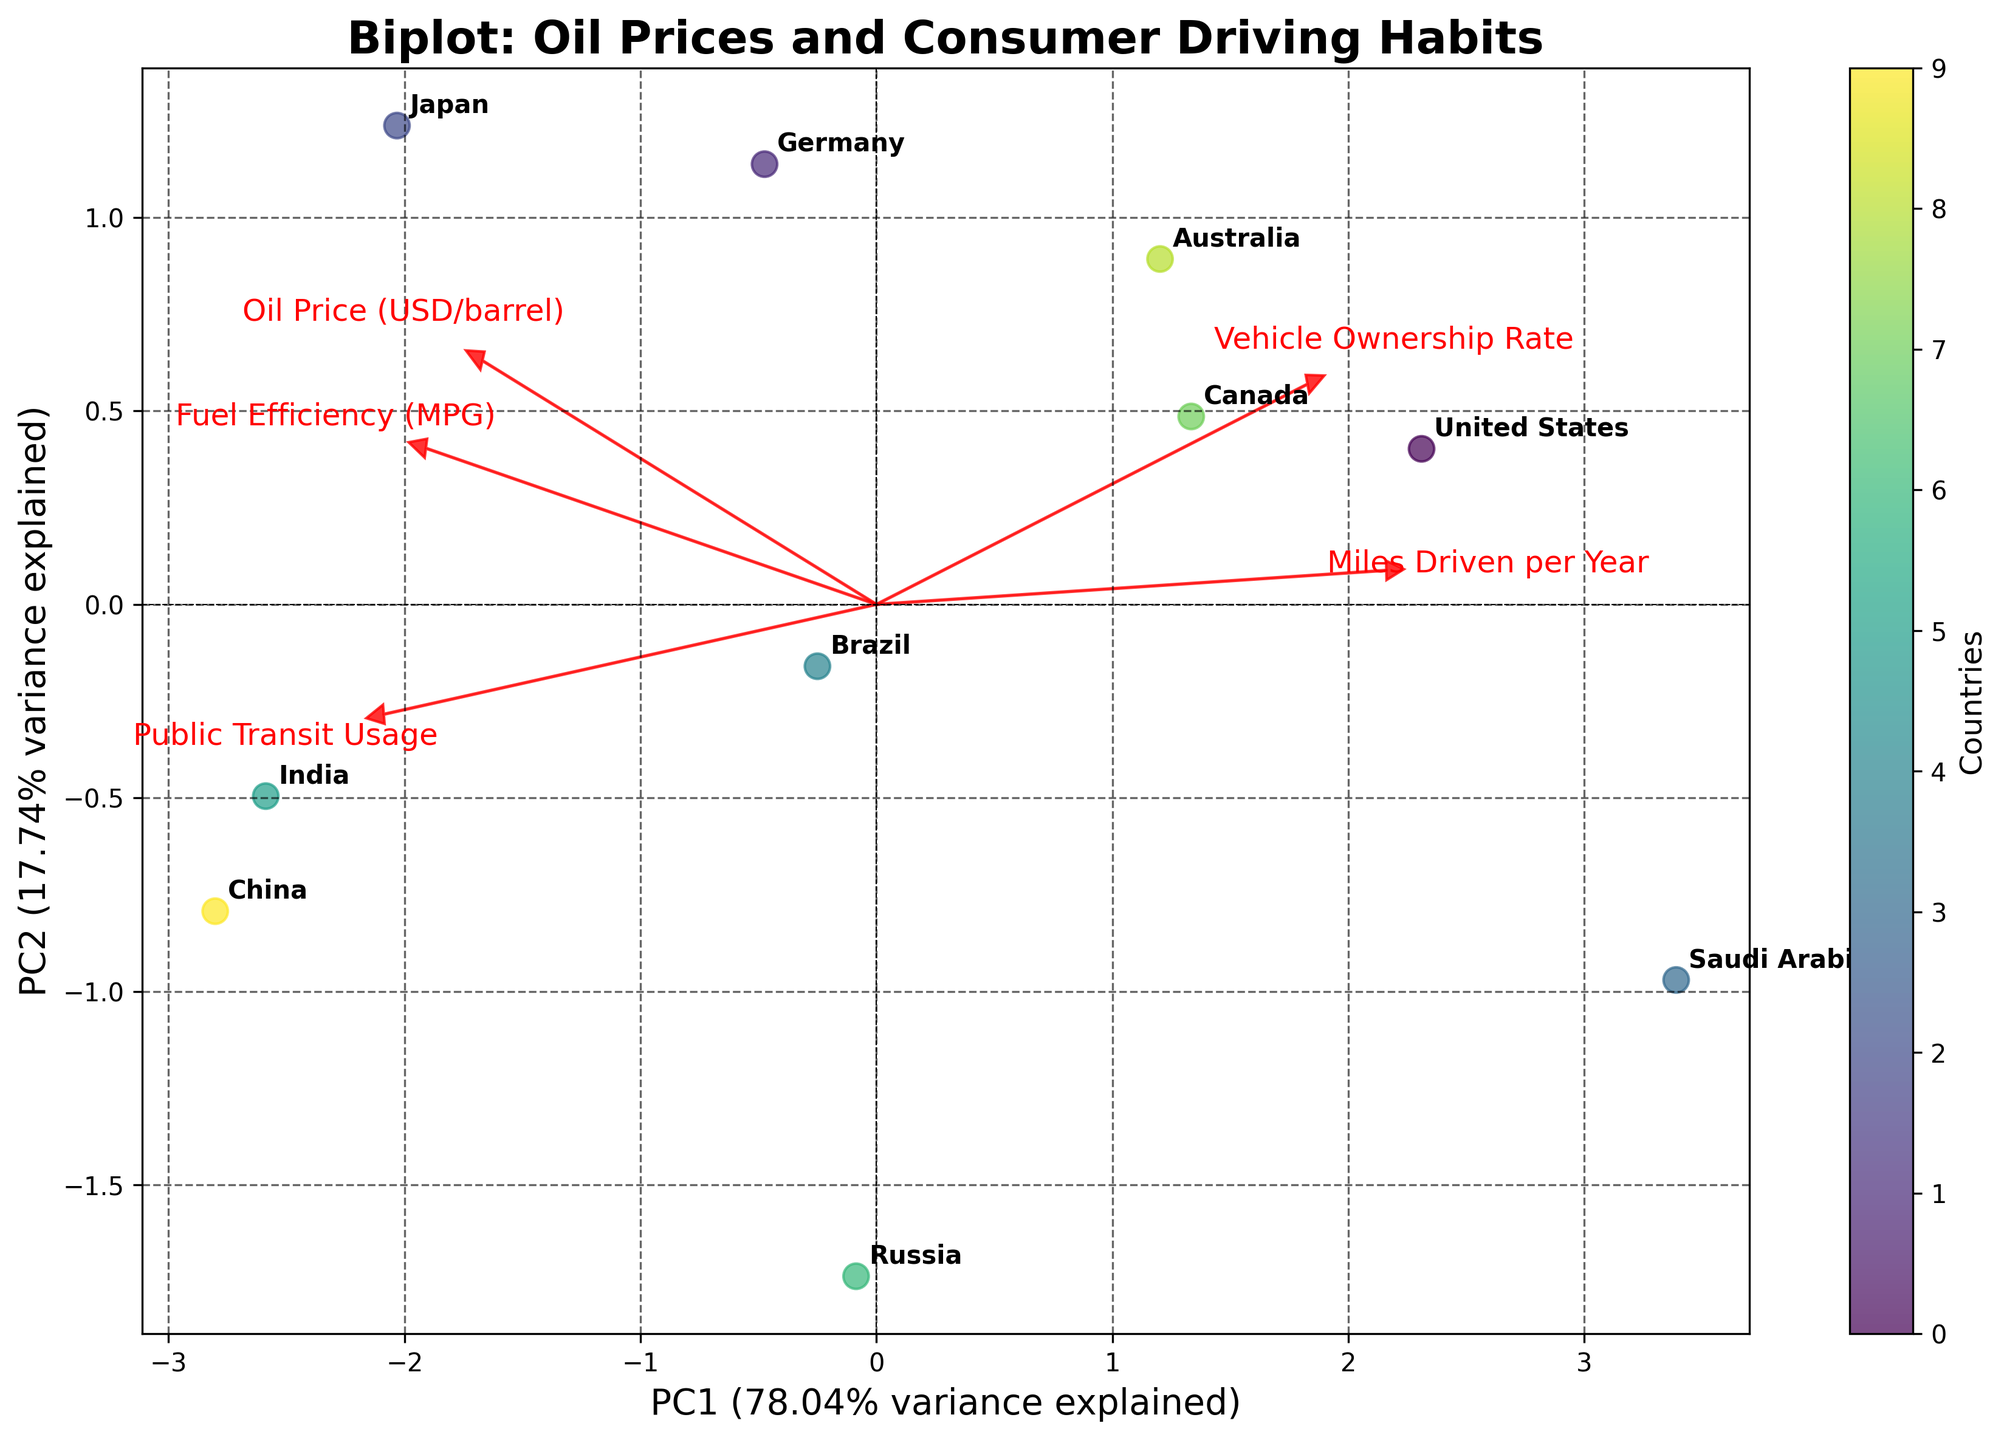What is the title of the plot? The title of the plot is written at the top and it reads "Biplot: Oil Prices and Consumer Driving Habits."
Answer: Biplot: Oil Prices and Consumer Driving Habits What do the axes represent? The axes are labeled "PC1" and "PC2," which represent the first and second principal components, respectively. The x-axis corresponds to PC1, and the y-axis corresponds to PC2.
Answer: PC1 and PC2 How many countries are represented in the plot? Each data point represents a country, and by counting the annotations, we can see that there are 10 different countries represented on the plot.
Answer: 10 Which country is most positively correlated with public transit usage? To find the country most positively correlated with public transit usage, we look for the country closest to the vector labeled "Public Transit Usage." From the plot, India is the closest to this vector.
Answer: India Which feature has the highest correlation with the first principal component (PC1)? The arrow with the longest projection on the PC1 axis represents the highest correlation. From the plot, "Miles Driven per Year" has the longest projection on the PC1 axis.
Answer: Miles Driven per Year Are Canada and Germany more similar or different according to the plot? Canada and Germany are relatively close to each other on the plot, suggesting that their driving habits and oil prices are more similar than different according to the principal components analysis.
Answer: More similar Which feature is most negatively correlated with PC2? The feature with the longest arrow pointing downward on the PC2 axis is negatively correlated with PC2. From the plot, "Public Transit Usage" has the longest arrow pointing downward on the PC2 axis.
Answer: Public Transit Usage How much variance is explained by the first principal component (PC1)? The percentage of variance explained by PC1 is indicated in the x-axis label within parentheses. According to the plot, PC1 explains 42.56% of the variance.
Answer: 42.56% Which two countries are closest to each other on the biplot? By observing the plot, Canada and Australia appear to be closest to each other, suggesting similar driving habits and oil prices.
Answer: Canada and Australia What can you infer about the correlation between fuel efficiency and miles driven? The arrows for "Fuel Efficiency (MPG)" and "Miles Driven per Year" are pointing in roughly opposite directions, suggesting a negative correlation between these variables. This indicates that countries with higher miles driven per year tend to have lower fuel efficiency.
Answer: Negative correlation 